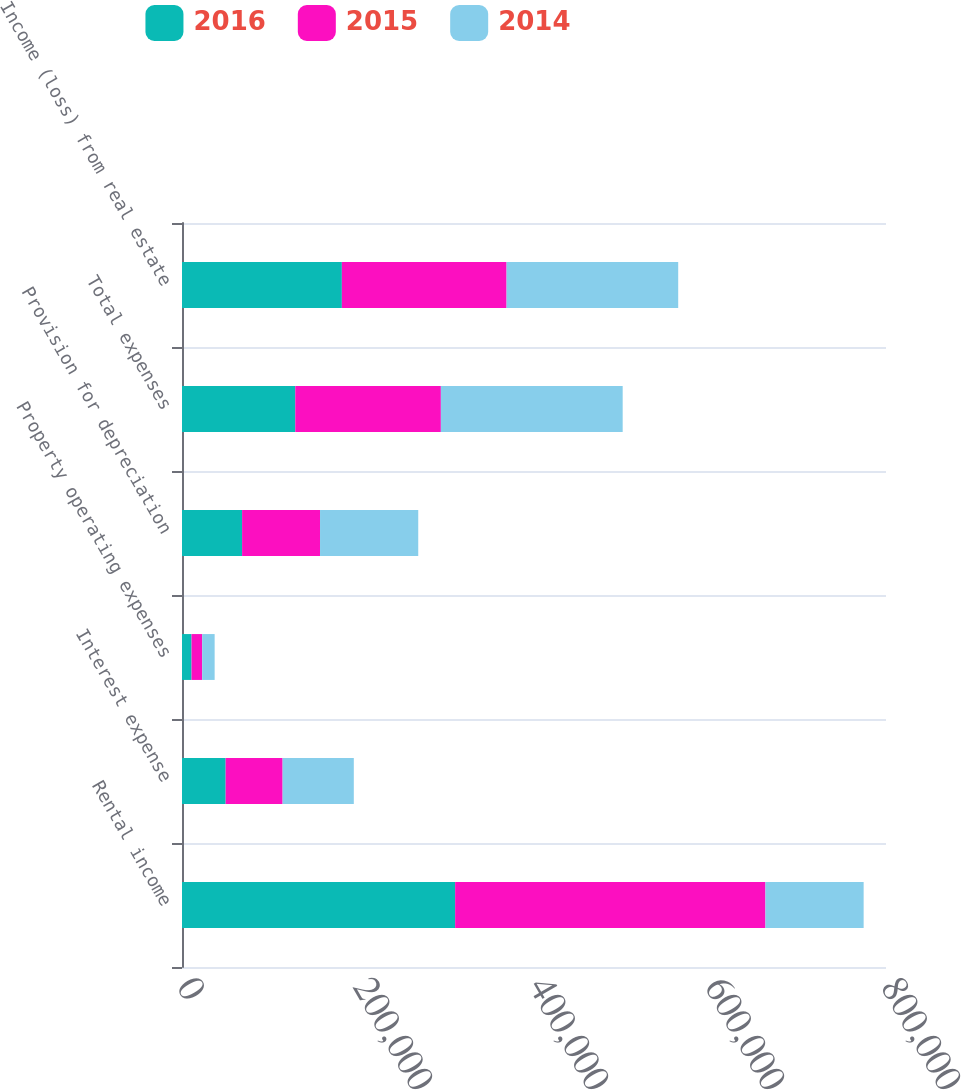<chart> <loc_0><loc_0><loc_500><loc_500><stacked_bar_chart><ecel><fcel>Rental income<fcel>Interest expense<fcel>Property operating expenses<fcel>Provision for depreciation<fcel>Total expenses<fcel>Income (loss) from real estate<nl><fcel>2016<fcel>310390<fcel>49599<fcel>10846<fcel>68280<fcel>128725<fcel>181665<nl><fcel>2015<fcel>352615<fcel>64741<fcel>12117<fcel>88580<fcel>165438<fcel>187177<nl><fcel>2014<fcel>111593<fcel>80893<fcel>14127<fcel>111593<fcel>206613<fcel>195027<nl></chart> 